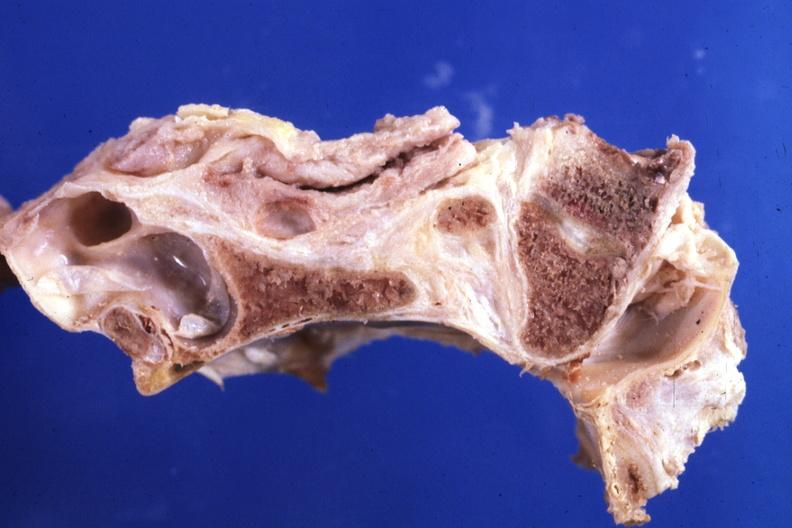s bone , calvarium present?
Answer the question using a single word or phrase. Yes 